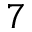Convert formula to latex. <formula><loc_0><loc_0><loc_500><loc_500>7</formula> 